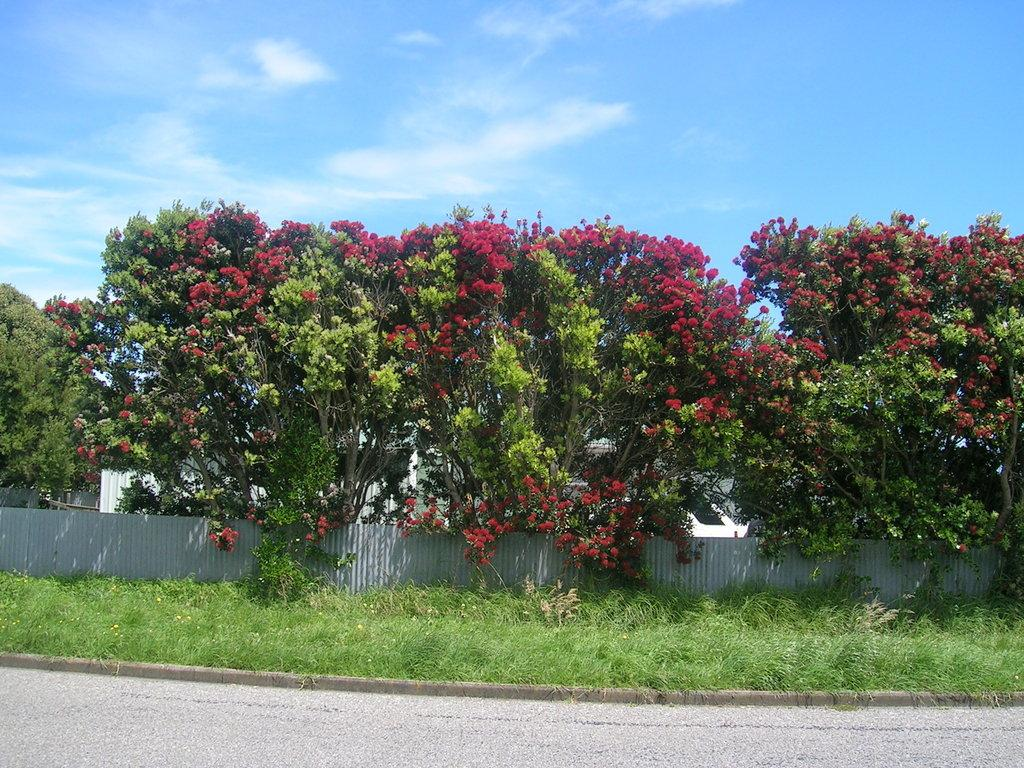What can be seen in the sky in the image? The sky with clouds is visible in the image. What type of structures are present in the image? There are buildings in the image. What type of vegetation is present in the image? Trees are present in the image. What type of barrier is visible in the image? There is a fence in the image. What type of ground surface is visible in the image? Grass is visible in the image. What type of transportation route is present in the image? There is a road in the image. What type of chin can be seen on the trees in the image? There is no chin present on the trees in the image; they are simply trees with branches and leaves. What type of plants are growing on the road in the image? There are no plants growing on the road in the image; the road is a paved surface for transportation. 